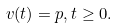Convert formula to latex. <formula><loc_0><loc_0><loc_500><loc_500>v ( t ) = p , t \geq 0 .</formula> 